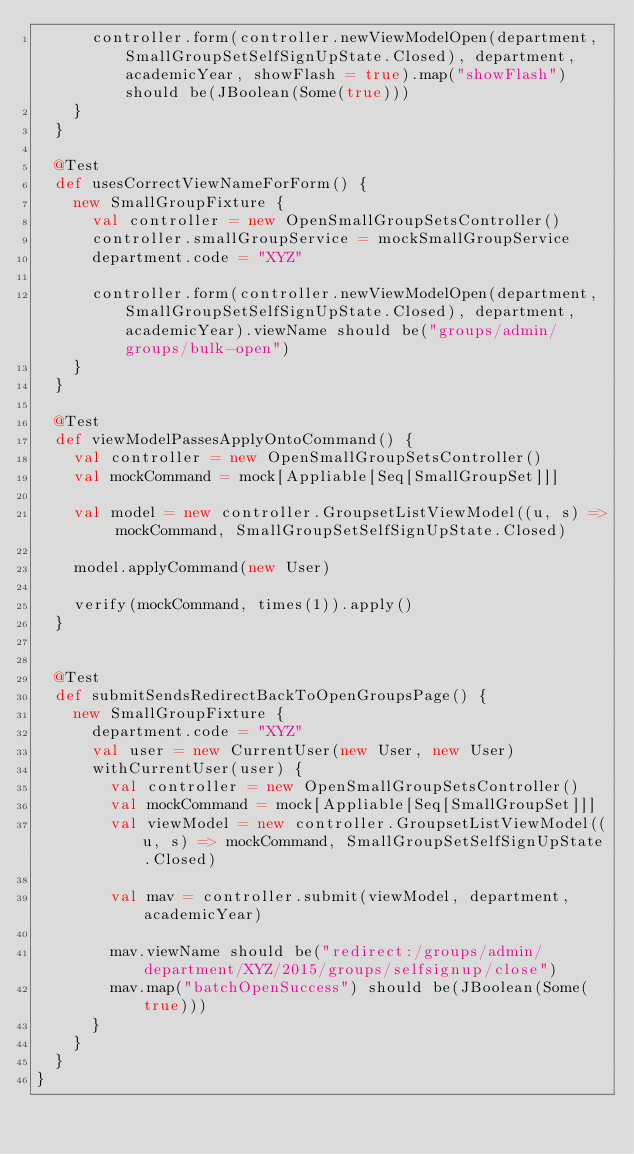Convert code to text. <code><loc_0><loc_0><loc_500><loc_500><_Scala_>      controller.form(controller.newViewModelOpen(department, SmallGroupSetSelfSignUpState.Closed), department, academicYear, showFlash = true).map("showFlash") should be(JBoolean(Some(true)))
    }
  }

  @Test
  def usesCorrectViewNameForForm() {
    new SmallGroupFixture {
      val controller = new OpenSmallGroupSetsController()
      controller.smallGroupService = mockSmallGroupService
      department.code = "XYZ"

      controller.form(controller.newViewModelOpen(department, SmallGroupSetSelfSignUpState.Closed), department, academicYear).viewName should be("groups/admin/groups/bulk-open")
    }
  }

  @Test
  def viewModelPassesApplyOntoCommand() {
    val controller = new OpenSmallGroupSetsController()
    val mockCommand = mock[Appliable[Seq[SmallGroupSet]]]

    val model = new controller.GroupsetListViewModel((u, s) => mockCommand, SmallGroupSetSelfSignUpState.Closed)

    model.applyCommand(new User)

    verify(mockCommand, times(1)).apply()
  }


  @Test
  def submitSendsRedirectBackToOpenGroupsPage() {
    new SmallGroupFixture {
      department.code = "XYZ"
      val user = new CurrentUser(new User, new User)
      withCurrentUser(user) {
        val controller = new OpenSmallGroupSetsController()
        val mockCommand = mock[Appliable[Seq[SmallGroupSet]]]
        val viewModel = new controller.GroupsetListViewModel((u, s) => mockCommand, SmallGroupSetSelfSignUpState.Closed)

        val mav = controller.submit(viewModel, department, academicYear)

        mav.viewName should be("redirect:/groups/admin/department/XYZ/2015/groups/selfsignup/close")
        mav.map("batchOpenSuccess") should be(JBoolean(Some(true)))
      }
    }
  }
}
</code> 